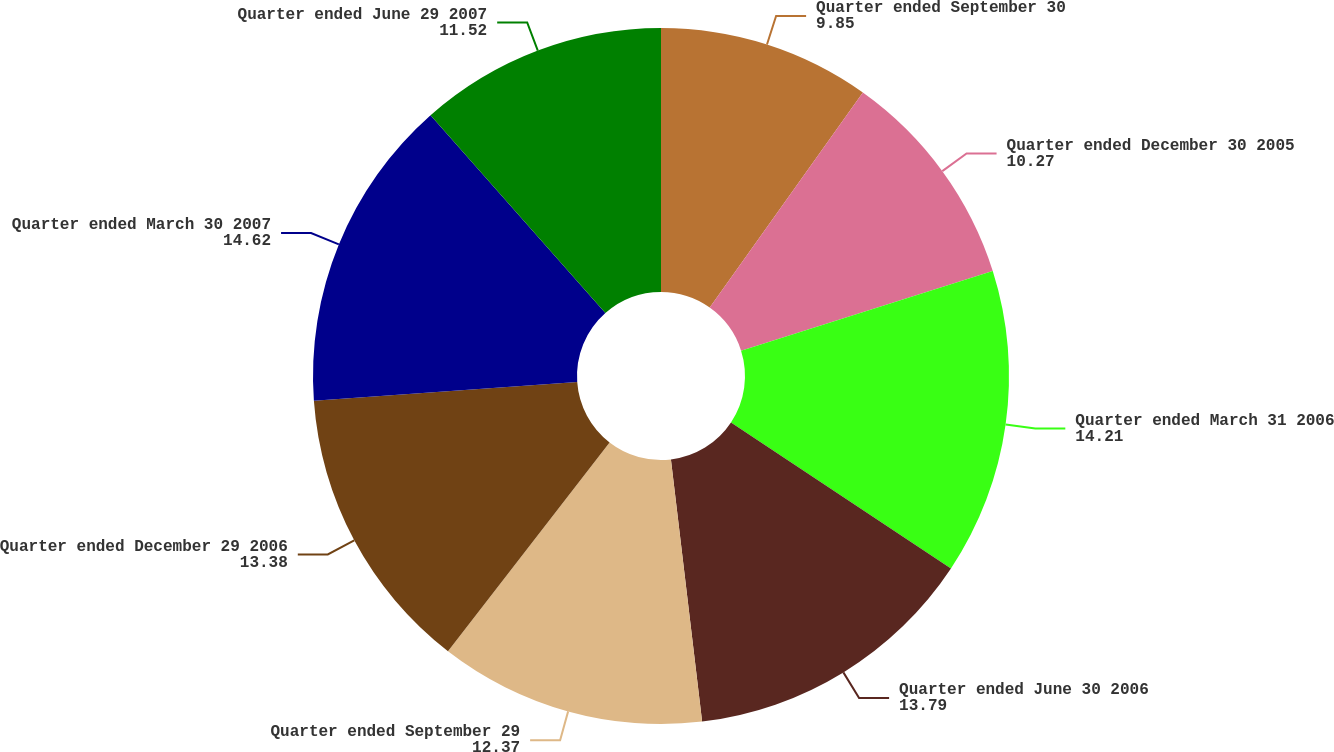Convert chart. <chart><loc_0><loc_0><loc_500><loc_500><pie_chart><fcel>Quarter ended September 30<fcel>Quarter ended December 30 2005<fcel>Quarter ended March 31 2006<fcel>Quarter ended June 30 2006<fcel>Quarter ended September 29<fcel>Quarter ended December 29 2006<fcel>Quarter ended March 30 2007<fcel>Quarter ended June 29 2007<nl><fcel>9.85%<fcel>10.27%<fcel>14.21%<fcel>13.79%<fcel>12.37%<fcel>13.38%<fcel>14.62%<fcel>11.52%<nl></chart> 